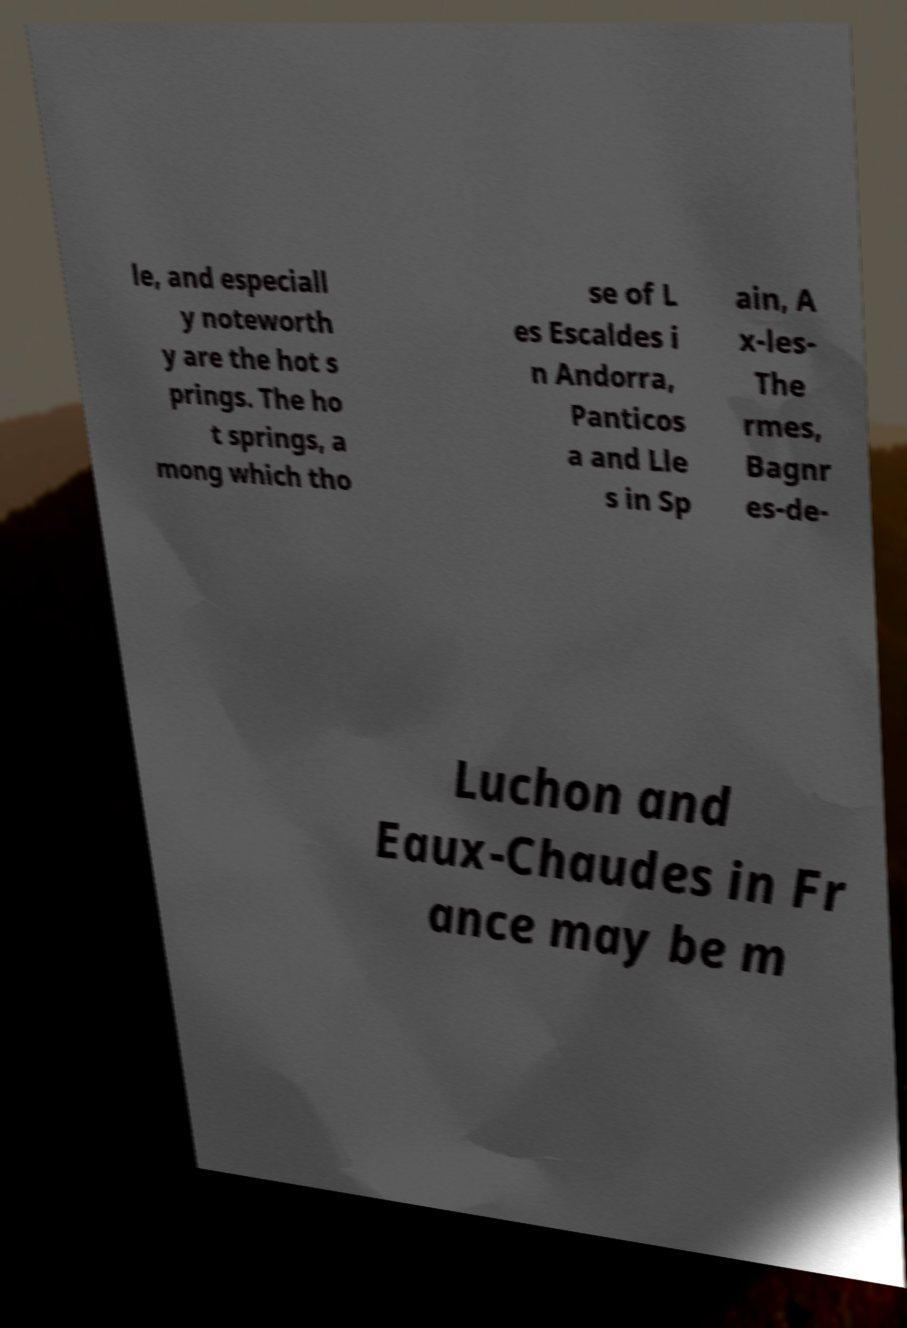Can you read and provide the text displayed in the image?This photo seems to have some interesting text. Can you extract and type it out for me? le, and especiall y noteworth y are the hot s prings. The ho t springs, a mong which tho se of L es Escaldes i n Andorra, Panticos a and Lle s in Sp ain, A x-les- The rmes, Bagnr es-de- Luchon and Eaux-Chaudes in Fr ance may be m 